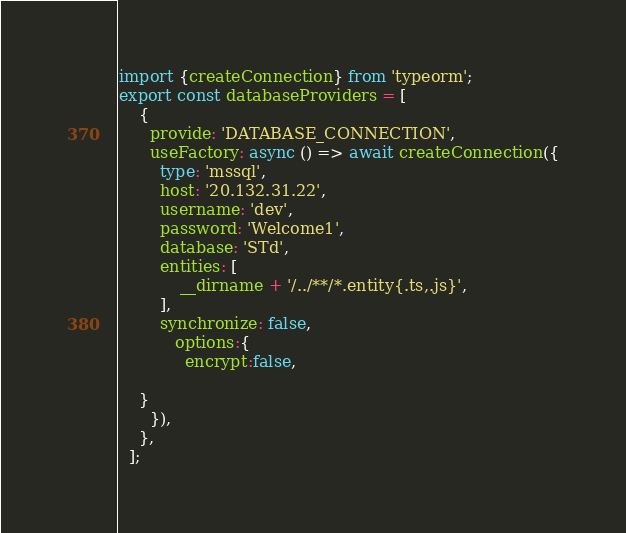<code> <loc_0><loc_0><loc_500><loc_500><_TypeScript_>import {createConnection} from 'typeorm';
export const databaseProviders = [
    {
      provide: 'DATABASE_CONNECTION',
      useFactory: async () => await createConnection({
        type: 'mssql',
        host: '20.132.31.22',
        username: 'dev',
        password: 'Welcome1',
        database: 'STd',
        entities: [
            __dirname + '/../**/*.entity{.ts,.js}',
        ],
        synchronize: false,
           options:{
             encrypt:false,

    }
      }),
    },
  ];</code> 